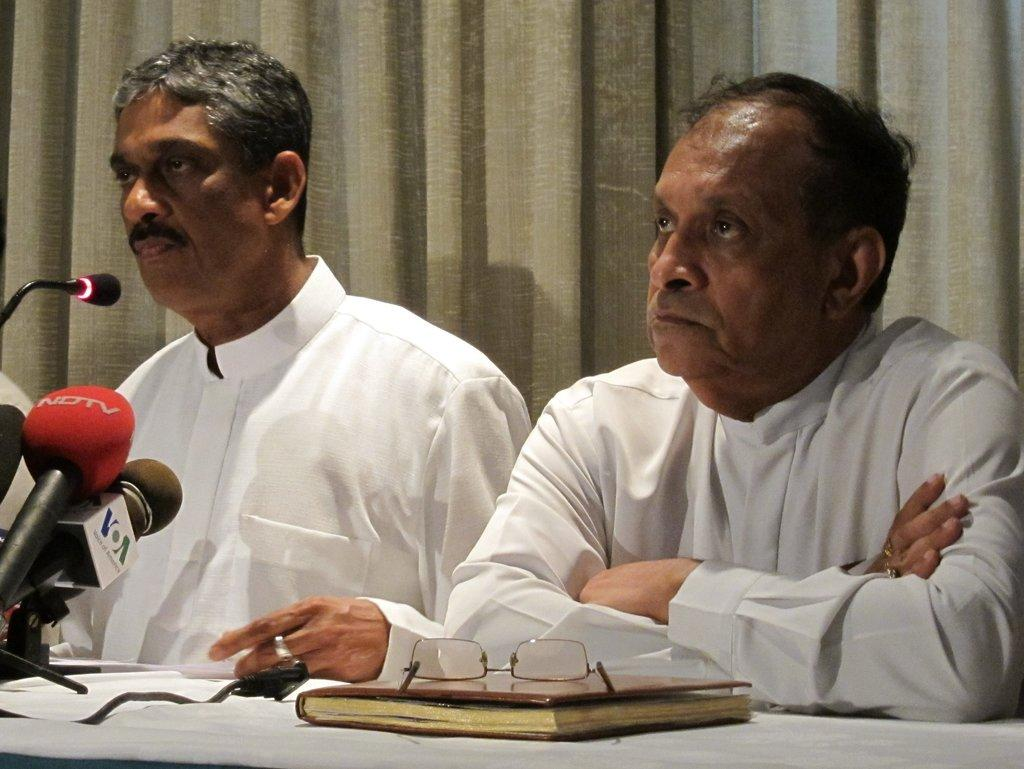How many people are present in the image? There are two men sitting in the image. What are the men wearing? The men are wearing clothes. What object can be seen near the men? There is a book in the image. What is placed on the book? Spectacles are placed on the book. What equipment is visible in the image? There are microphones in the image. What type of window treatment is present in the image? There are curtains in the image. What type of zephyr is being served in the image? There is no zephyr present in the image; it is not a food or beverage item. How many bowls of oatmeal are visible in the image? There are no bowls of oatmeal present in the image. 